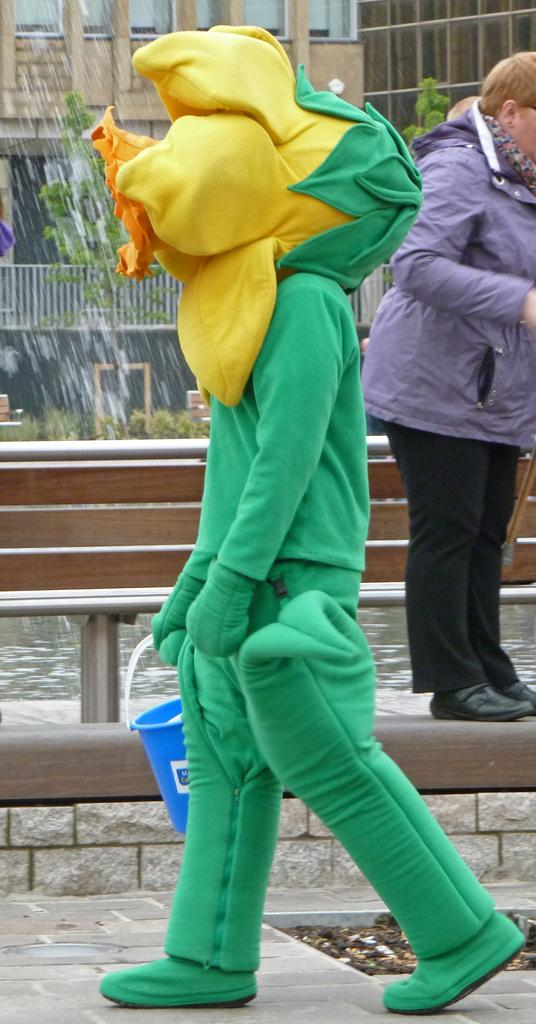What can be seen in the image? There is a person in the image. Can you describe the person's appearance? The person is wearing a costume with green, yellow, and orange colors. What is the person holding in the image? The person is holding a blue color bucket. What is visible in the background of the image? There is a building, windows, trees, and another person standing in the background. What type of apple is the person eating in the image? There is no apple present in the image; the person is holding a blue color bucket. How many tickets does the person have in their hand in the image? There are no tickets visible in the image; the person is holding a blue color bucket. 